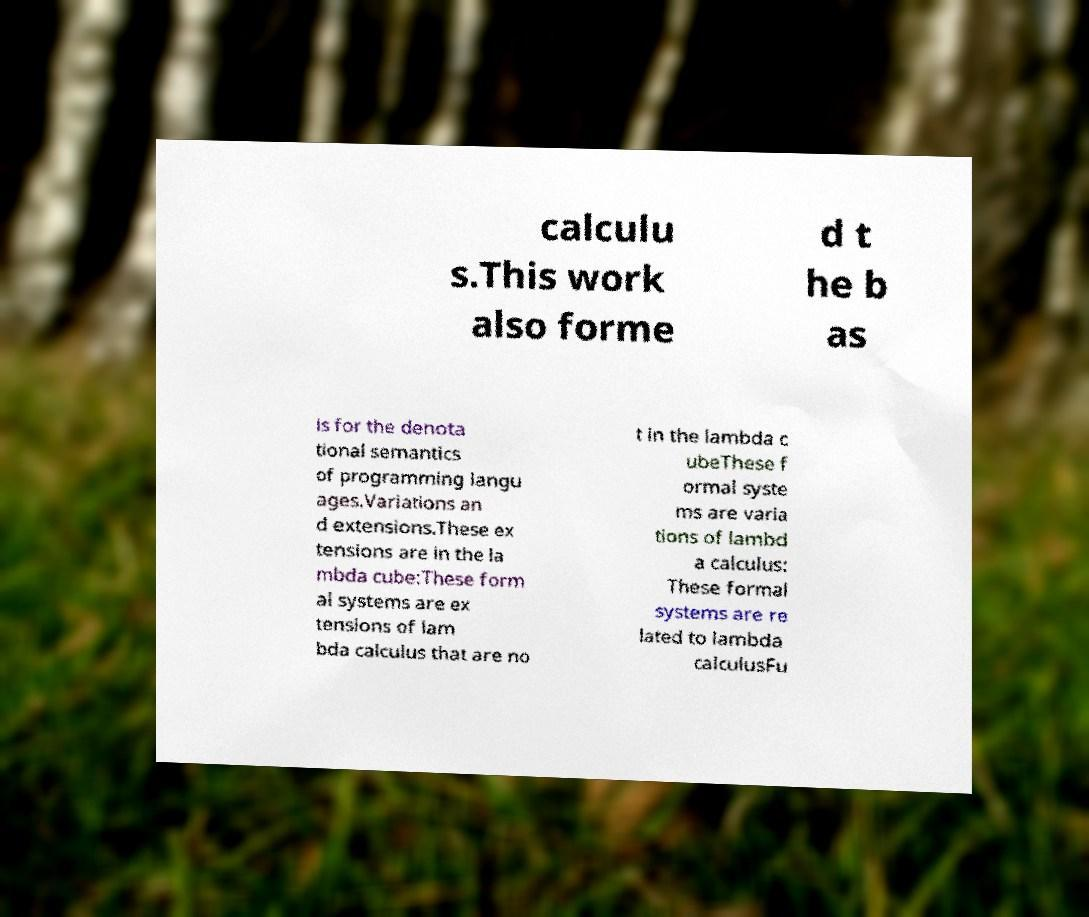Please identify and transcribe the text found in this image. calculu s.This work also forme d t he b as is for the denota tional semantics of programming langu ages.Variations an d extensions.These ex tensions are in the la mbda cube:These form al systems are ex tensions of lam bda calculus that are no t in the lambda c ubeThese f ormal syste ms are varia tions of lambd a calculus: These formal systems are re lated to lambda calculusFu 